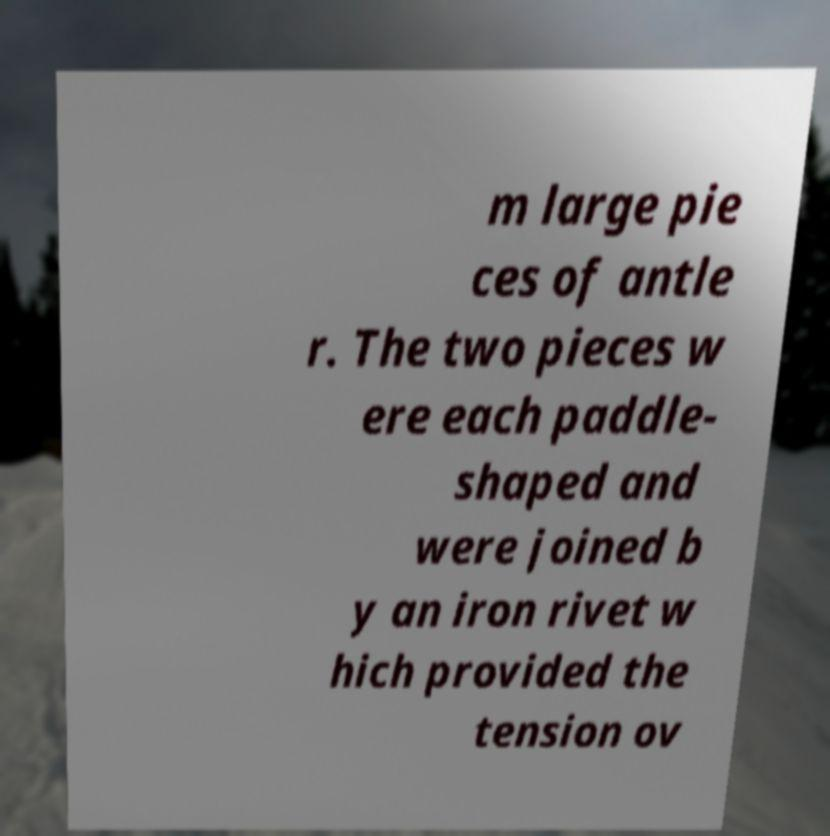Could you assist in decoding the text presented in this image and type it out clearly? m large pie ces of antle r. The two pieces w ere each paddle- shaped and were joined b y an iron rivet w hich provided the tension ov 